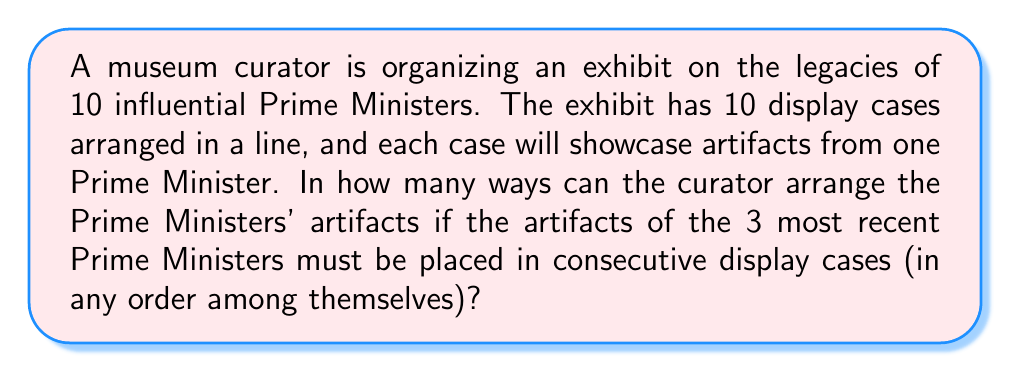Can you solve this math problem? Let's approach this step-by-step:

1) First, we can consider the 3 most recent Prime Ministers' artifacts as one unit. This leaves us with 8 units to arrange: the group of 3 recent PMs and 7 individual earlier PMs.

2) We can arrange these 8 units in $8!$ ways.

3) However, within the group of 3 recent PMs, their artifacts can also be arranged in $3!$ ways.

4) By the multiplication principle, the total number of arrangements is:

   $$ 8! \times 3! $$

5) Let's calculate this:
   $$ 8! \times 3! = 40,320 \times 6 = 241,920 $$

Thus, there are 241,920 ways to arrange the artifacts.
Answer: 241,920 